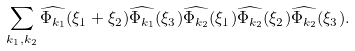Convert formula to latex. <formula><loc_0><loc_0><loc_500><loc_500>\sum _ { k _ { 1 } , k _ { 2 } } \widehat { \Phi _ { k _ { 1 } } } ( \xi _ { 1 } + \xi _ { 2 } ) \widehat { \Phi _ { k _ { 1 } } } ( \xi _ { 3 } ) \widehat { \Phi _ { k _ { 2 } } } ( \xi _ { 1 } ) \widehat { \Phi _ { k _ { 2 } } } ( \xi _ { 2 } ) \widehat { \Phi _ { k _ { 2 } } } ( \xi _ { 3 } ) .</formula> 